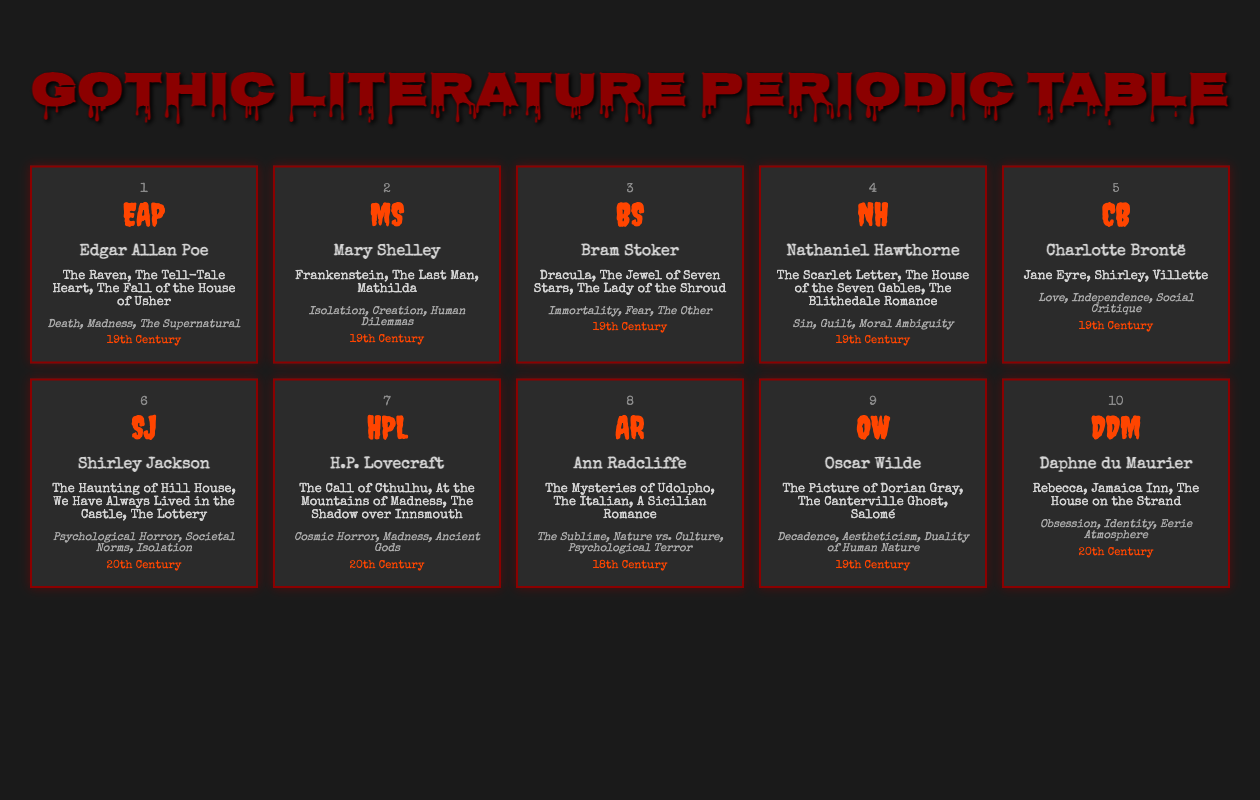What notable work is associated with Edgar Allan Poe? From the table, it's clear that Edgar Allan Poe has three notable works listed: "The Raven," "The Tell-Tale Heart," and "The Fall of the House of Usher."
Answer: The Raven Which authors wrote their notable works in the 19th Century? A review of the table shows that Edgar Allan Poe, Mary Shelley, Bram Stoker, Nathaniel Hawthorne, Charlotte Brontë, Oscar Wilde, and Ann Radcliffe all have their works classified under the 19th Century.
Answer: Edgar Allan Poe, Mary Shelley, Bram Stoker, Nathaniel Hawthorne, Charlotte Brontë, Oscar Wilde, Ann Radcliffe Does Shirley Jackson explore themes of psychological horror? The table lists the themes of Shirley Jackson's works, which include "Psychological Horror." Therefore, the answer is yes.
Answer: Yes What is the total number of notable works listed for Nathaniel Hawthorne and H.P. Lovecraft combined? Nathaniel Hawthorne has three notable works and H.P. Lovecraft also has three notable works. Adding them together gives us 3 + 3 = 6.
Answer: 6 Which author focuses on themes of isolation and identity in their works? The table shows that Mary Shelley explores themes of "Isolation," while Daphne du Maurier focuses on "Identity." Hence, both authors deal with these themes.
Answer: Mary Shelley, Daphne du Maurier How many authors listed focus on themes related to general psychological horror? The table indicates that only Shirley Jackson's themes include "Psychological Horror." Thus, the number of authors focusing on this theme is 1.
Answer: 1 Which author has the most diverse set of themes? Analyzing the themes of each author, Charlotte Brontë has three distinct themes: "Love," "Independence," and "Social Critique." Bram Stoker’s themes all revolve around fear and immortality, which is less diverse. Therefore, Charlotte Brontë demonstrates a broader range.
Answer: Charlotte Brontë Is there any author in the table whose works belong to the 18th Century? Yes, the table lists Ann Radcliffe as part of the 18th Century group, confirming that there is at least one author from that period.
Answer: Yes 